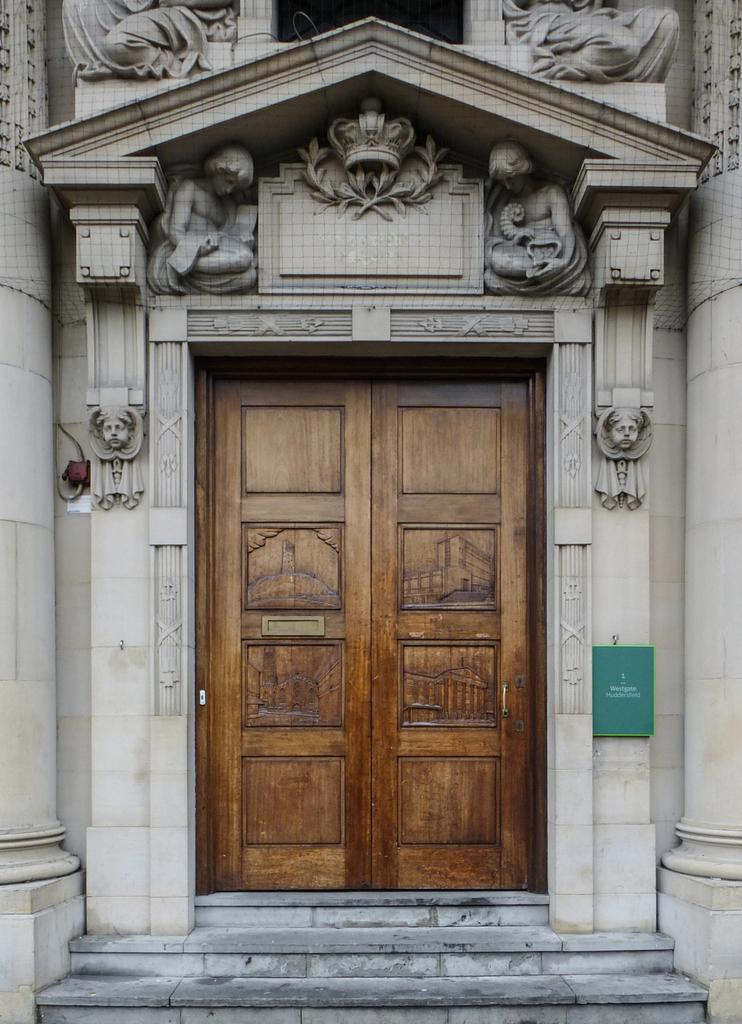What type of architectural feature can be seen in the image? There are stairs in the image. What structure is visible in the background? There is a building in the image. What decorative elements are present near the building? There are sculptures near the building. What is the color and material of the door in the image? There is a large brown-colored door in the image. What type of lumber is used to construct the door in the image? There is no information about the type of lumber used to construct the door in the image. How many stitches are visible on the sculptures near the building? The sculptures near the building do not have any visible stitches. 